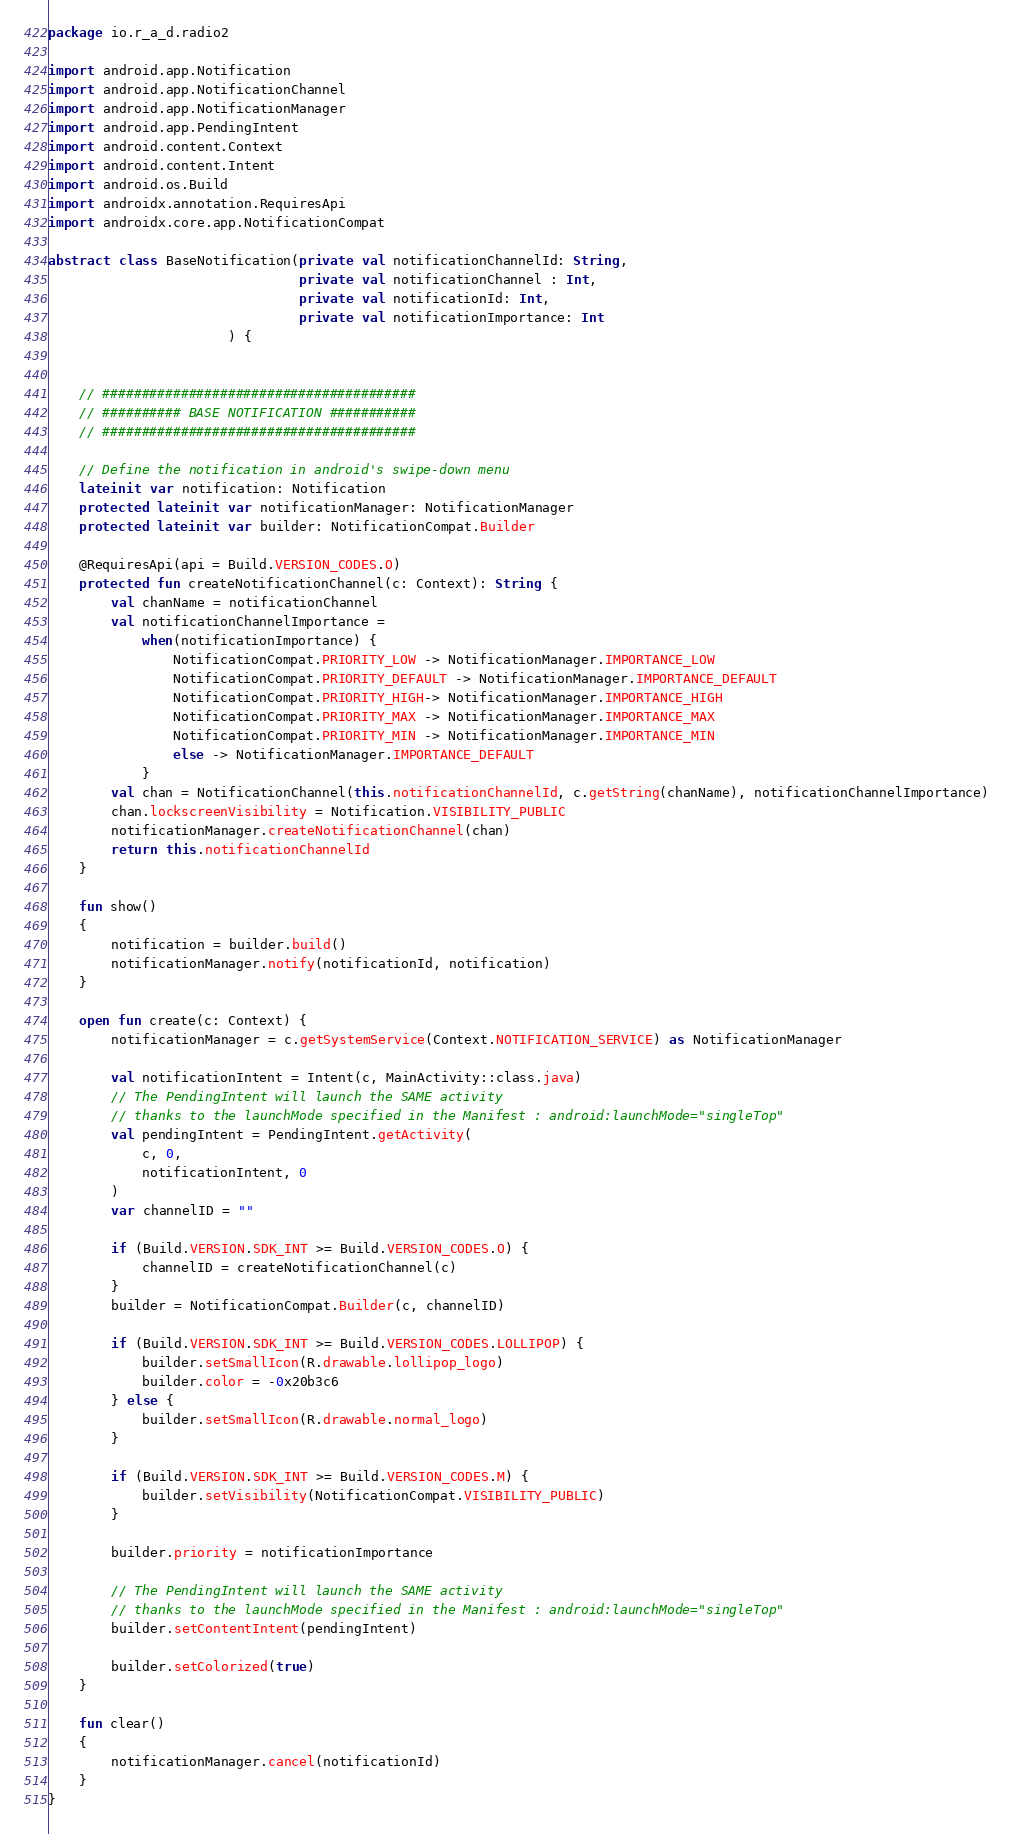<code> <loc_0><loc_0><loc_500><loc_500><_Kotlin_>package io.r_a_d.radio2

import android.app.Notification
import android.app.NotificationChannel
import android.app.NotificationManager
import android.app.PendingIntent
import android.content.Context
import android.content.Intent
import android.os.Build
import androidx.annotation.RequiresApi
import androidx.core.app.NotificationCompat

abstract class BaseNotification(private val notificationChannelId: String,
                                private val notificationChannel : Int,
                                private val notificationId: Int,
                                private val notificationImportance: Int
                       ) {


    // ########################################
    // ########## BASE NOTIFICATION ###########
    // ########################################

    // Define the notification in android's swipe-down menu
    lateinit var notification: Notification
    protected lateinit var notificationManager: NotificationManager
    protected lateinit var builder: NotificationCompat.Builder

    @RequiresApi(api = Build.VERSION_CODES.O)
    protected fun createNotificationChannel(c: Context): String {
        val chanName = notificationChannel
        val notificationChannelImportance =
            when(notificationImportance) {
                NotificationCompat.PRIORITY_LOW -> NotificationManager.IMPORTANCE_LOW
                NotificationCompat.PRIORITY_DEFAULT -> NotificationManager.IMPORTANCE_DEFAULT
                NotificationCompat.PRIORITY_HIGH-> NotificationManager.IMPORTANCE_HIGH
                NotificationCompat.PRIORITY_MAX -> NotificationManager.IMPORTANCE_MAX
                NotificationCompat.PRIORITY_MIN -> NotificationManager.IMPORTANCE_MIN
                else -> NotificationManager.IMPORTANCE_DEFAULT
            }
        val chan = NotificationChannel(this.notificationChannelId, c.getString(chanName), notificationChannelImportance)
        chan.lockscreenVisibility = Notification.VISIBILITY_PUBLIC
        notificationManager.createNotificationChannel(chan)
        return this.notificationChannelId
    }

    fun show()
    {
        notification = builder.build()
        notificationManager.notify(notificationId, notification)
    }

    open fun create(c: Context) {
        notificationManager = c.getSystemService(Context.NOTIFICATION_SERVICE) as NotificationManager

        val notificationIntent = Intent(c, MainActivity::class.java)
        // The PendingIntent will launch the SAME activity
        // thanks to the launchMode specified in the Manifest : android:launchMode="singleTop"
        val pendingIntent = PendingIntent.getActivity(
            c, 0,
            notificationIntent, 0
        )
        var channelID = ""

        if (Build.VERSION.SDK_INT >= Build.VERSION_CODES.O) {
            channelID = createNotificationChannel(c)
        }
        builder = NotificationCompat.Builder(c, channelID)

        if (Build.VERSION.SDK_INT >= Build.VERSION_CODES.LOLLIPOP) {
            builder.setSmallIcon(R.drawable.lollipop_logo)
            builder.color = -0x20b3c6
        } else {
            builder.setSmallIcon(R.drawable.normal_logo)
        }

        if (Build.VERSION.SDK_INT >= Build.VERSION_CODES.M) {
            builder.setVisibility(NotificationCompat.VISIBILITY_PUBLIC)
        }

        builder.priority = notificationImportance

        // The PendingIntent will launch the SAME activity
        // thanks to the launchMode specified in the Manifest : android:launchMode="singleTop"
        builder.setContentIntent(pendingIntent)

        builder.setColorized(true)
    }

    fun clear()
    {
        notificationManager.cancel(notificationId)
    }
}</code> 